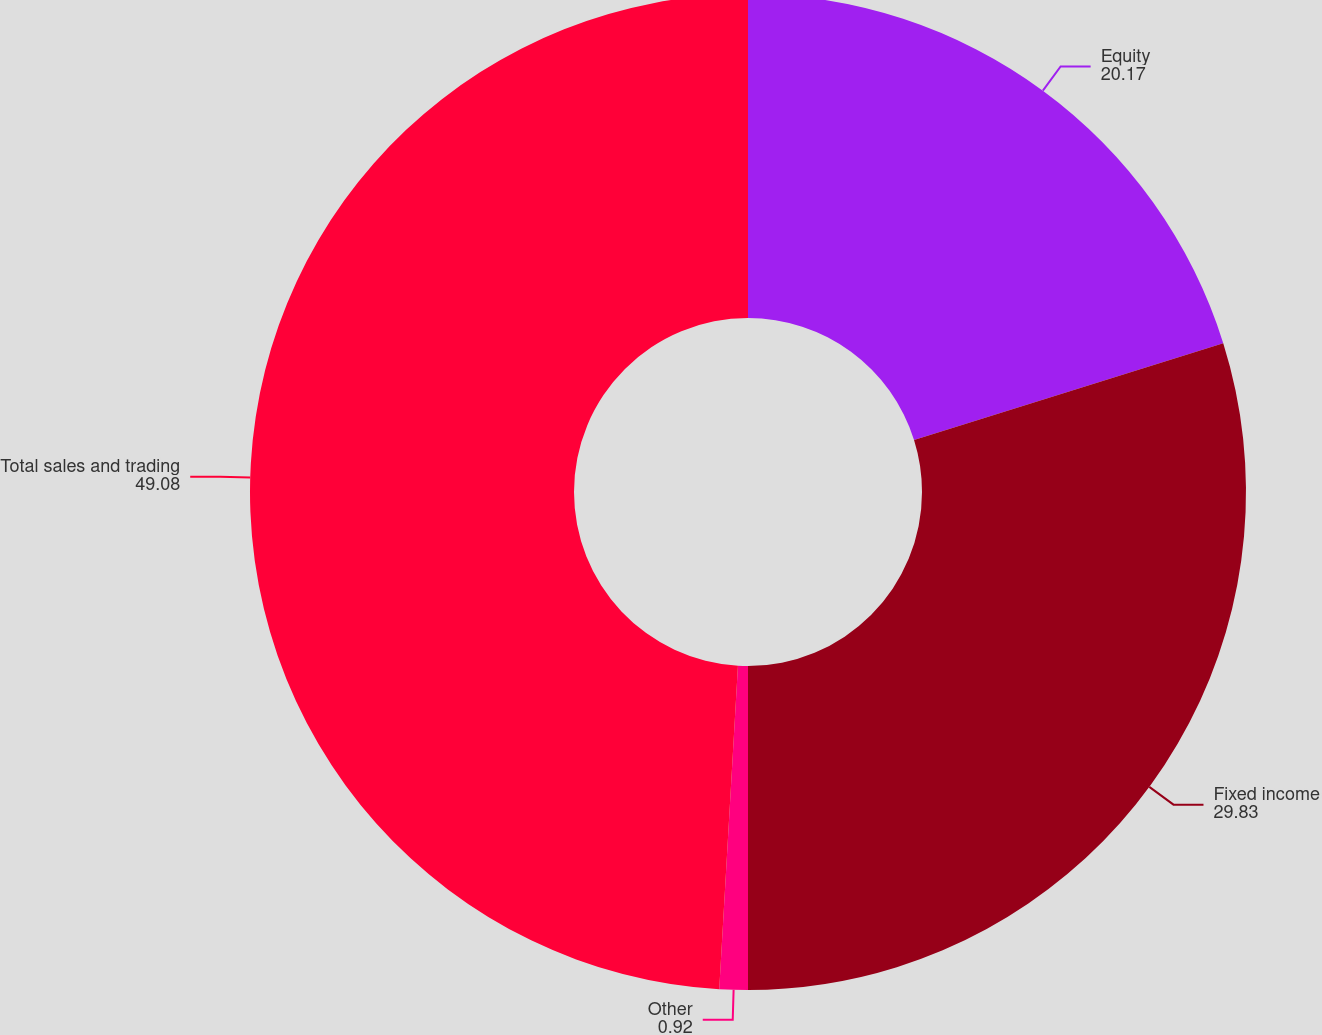Convert chart to OTSL. <chart><loc_0><loc_0><loc_500><loc_500><pie_chart><fcel>Equity<fcel>Fixed income<fcel>Other<fcel>Total sales and trading<nl><fcel>20.17%<fcel>29.83%<fcel>0.92%<fcel>49.08%<nl></chart> 